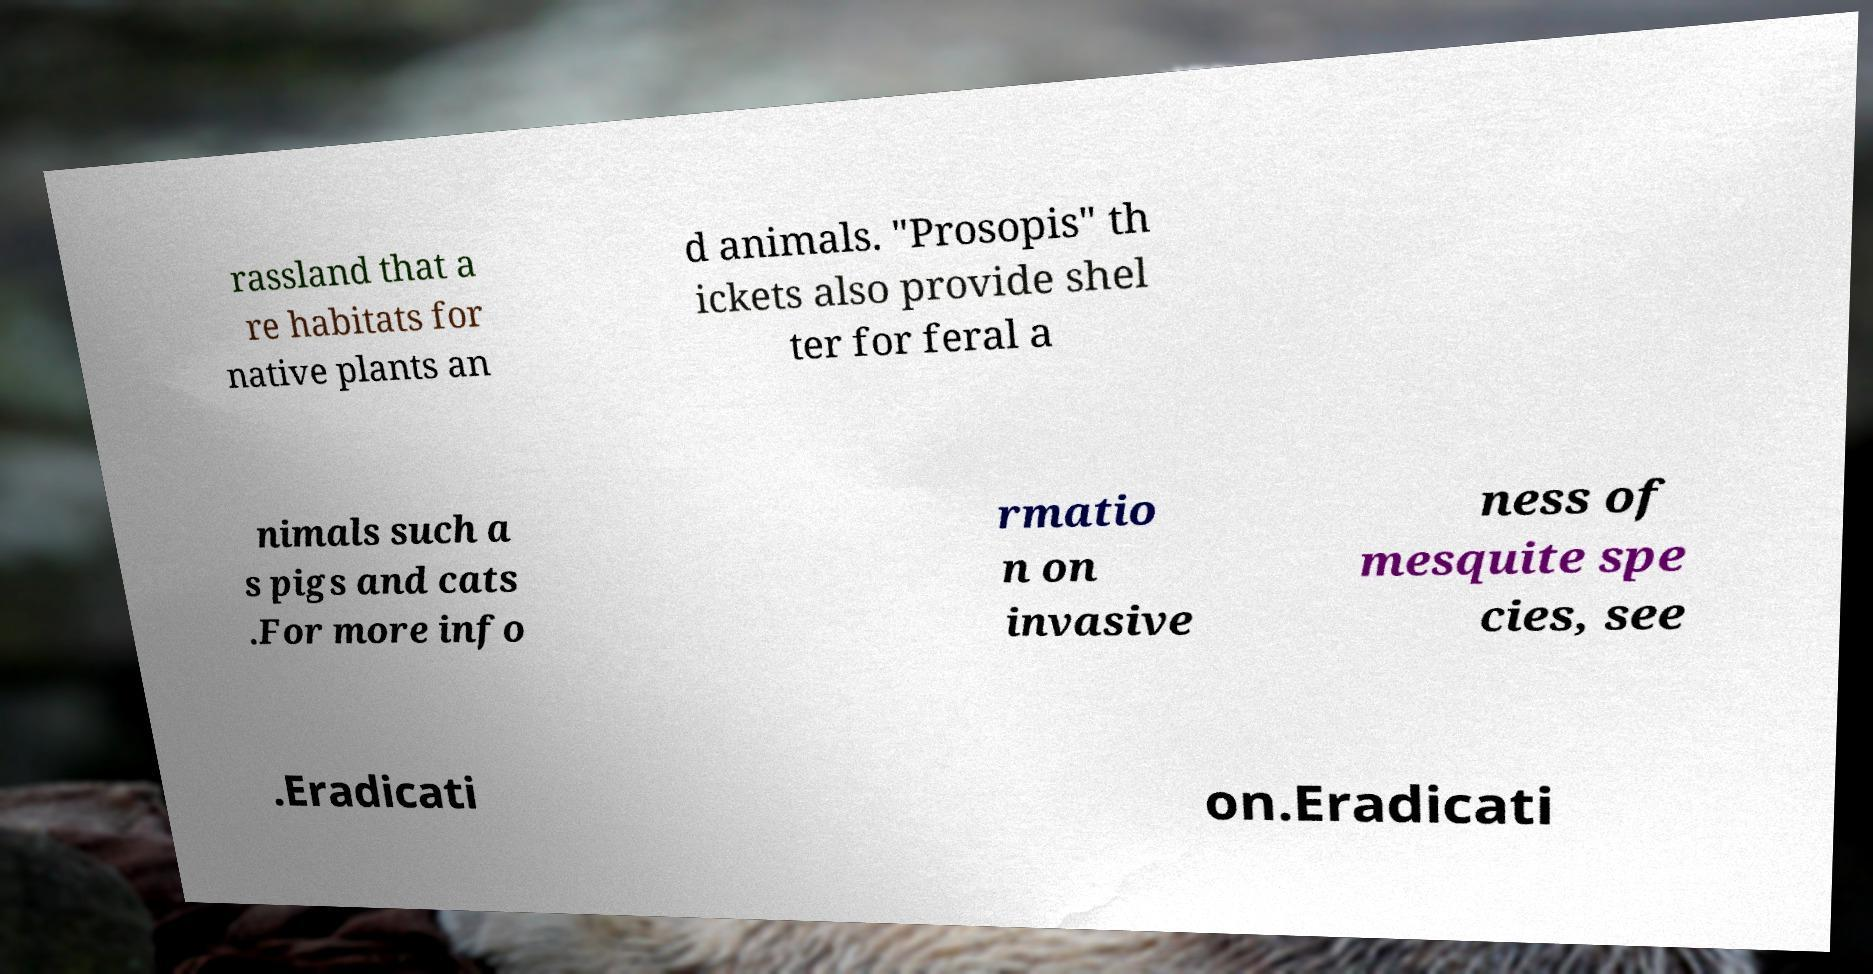Please read and relay the text visible in this image. What does it say? rassland that a re habitats for native plants an d animals. "Prosopis" th ickets also provide shel ter for feral a nimals such a s pigs and cats .For more info rmatio n on invasive ness of mesquite spe cies, see .Eradicati on.Eradicati 